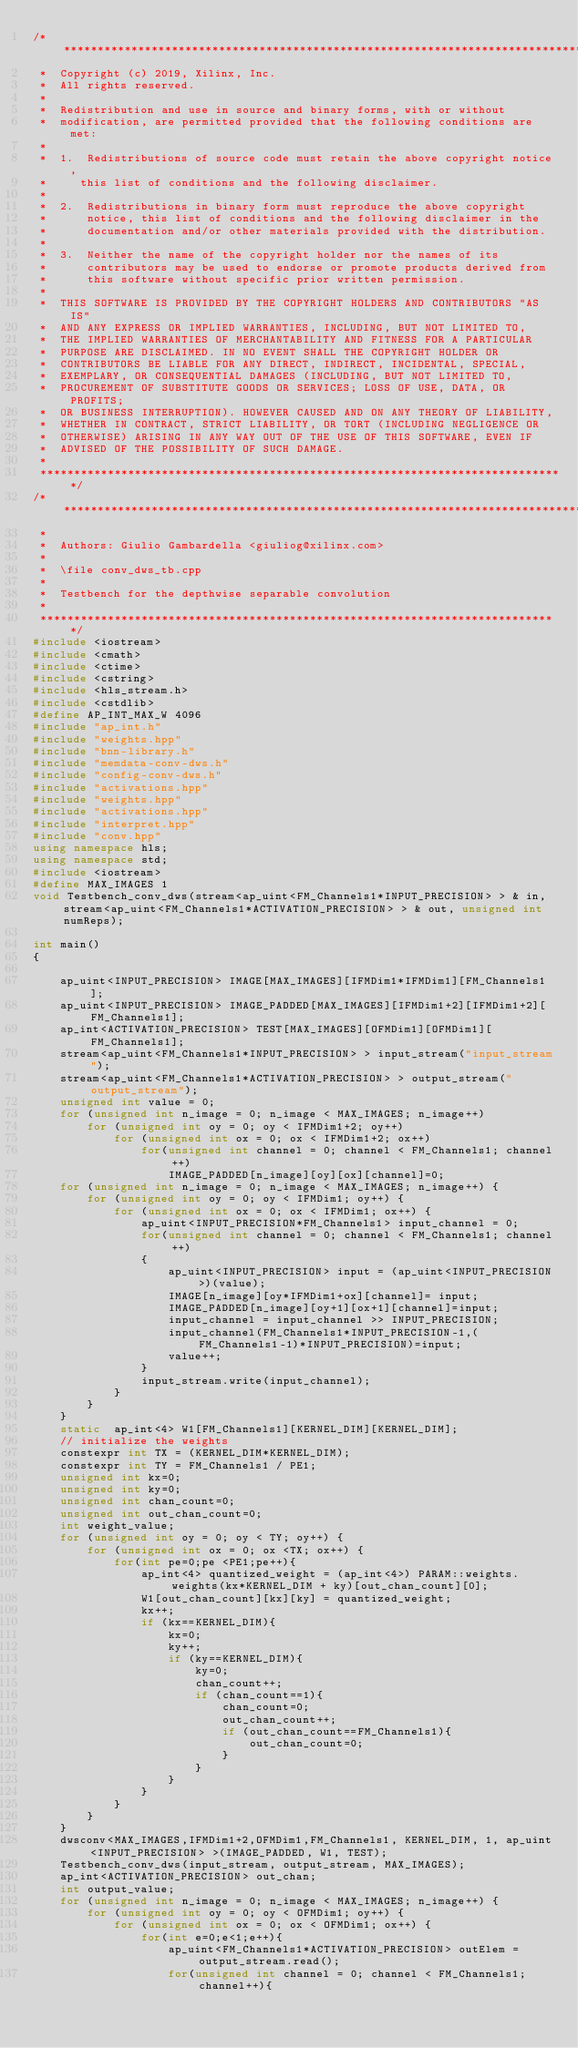<code> <loc_0><loc_0><loc_500><loc_500><_C++_>/******************************************************************************
 *  Copyright (c) 2019, Xilinx, Inc.
 *  All rights reserved.
 *
 *  Redistribution and use in source and binary forms, with or without
 *  modification, are permitted provided that the following conditions are met:
 *
 *  1.  Redistributions of source code must retain the above copyright notice,
 *     this list of conditions and the following disclaimer.
 *
 *  2.  Redistributions in binary form must reproduce the above copyright
 *      notice, this list of conditions and the following disclaimer in the
 *      documentation and/or other materials provided with the distribution.
 *
 *  3.  Neither the name of the copyright holder nor the names of its
 *      contributors may be used to endorse or promote products derived from
 *      this software without specific prior written permission.
 *
 *  THIS SOFTWARE IS PROVIDED BY THE COPYRIGHT HOLDERS AND CONTRIBUTORS "AS IS"
 *  AND ANY EXPRESS OR IMPLIED WARRANTIES, INCLUDING, BUT NOT LIMITED TO,
 *  THE IMPLIED WARRANTIES OF MERCHANTABILITY AND FITNESS FOR A PARTICULAR
 *  PURPOSE ARE DISCLAIMED. IN NO EVENT SHALL THE COPYRIGHT HOLDER OR
 *  CONTRIBUTORS BE LIABLE FOR ANY DIRECT, INDIRECT, INCIDENTAL, SPECIAL,
 *  EXEMPLARY, OR CONSEQUENTIAL DAMAGES (INCLUDING, BUT NOT LIMITED TO,
 *  PROCUREMENT OF SUBSTITUTE GOODS OR SERVICES; LOSS OF USE, DATA, OR PROFITS;
 *  OR BUSINESS INTERRUPTION). HOWEVER CAUSED AND ON ANY THEORY OF LIABILITY,
 *  WHETHER IN CONTRACT, STRICT LIABILITY, OR TORT (INCLUDING NEGLIGENCE OR
 *  OTHERWISE) ARISING IN ANY WAY OUT OF THE USE OF THIS SOFTWARE, EVEN IF
 *  ADVISED OF THE POSSIBILITY OF SUCH DAMAGE.
 *
 ******************************************************************************/
/******************************************************************************
 *
 *  Authors: Giulio Gambardella <giuliog@xilinx.com>
 *
 *  \file conv_dws_tb.cpp
 *
 *  Testbench for the depthwise separable convolution
 *
 *****************************************************************************/
#include <iostream>
#include <cmath>
#include <ctime>
#include <cstring>
#include <hls_stream.h>
#include <cstdlib>
#define AP_INT_MAX_W 4096
#include "ap_int.h"
#include "weights.hpp"
#include "bnn-library.h"
#include "memdata-conv-dws.h"
#include "config-conv-dws.h"
#include "activations.hpp"
#include "weights.hpp"
#include "activations.hpp"
#include "interpret.hpp"
#include "conv.hpp"
using namespace hls;
using namespace std;
#include <iostream>
#define MAX_IMAGES 1
void Testbench_conv_dws(stream<ap_uint<FM_Channels1*INPUT_PRECISION> > & in, stream<ap_uint<FM_Channels1*ACTIVATION_PRECISION> > & out, unsigned int numReps);

int main()
{

	ap_uint<INPUT_PRECISION> IMAGE[MAX_IMAGES][IFMDim1*IFMDim1][FM_Channels1];
	ap_uint<INPUT_PRECISION> IMAGE_PADDED[MAX_IMAGES][IFMDim1+2][IFMDim1+2][FM_Channels1];
	ap_int<ACTIVATION_PRECISION> TEST[MAX_IMAGES][OFMDim1][OFMDim1][FM_Channels1];
	stream<ap_uint<FM_Channels1*INPUT_PRECISION> > input_stream("input_stream");
	stream<ap_uint<FM_Channels1*ACTIVATION_PRECISION> > output_stream("output_stream");
	unsigned int value = 0;
	for (unsigned int n_image = 0; n_image < MAX_IMAGES; n_image++)
		for (unsigned int oy = 0; oy < IFMDim1+2; oy++)
			for (unsigned int ox = 0; ox < IFMDim1+2; ox++)
				for(unsigned int channel = 0; channel < FM_Channels1; channel++)
					IMAGE_PADDED[n_image][oy][ox][channel]=0;
	for (unsigned int n_image = 0; n_image < MAX_IMAGES; n_image++) {
		for (unsigned int oy = 0; oy < IFMDim1; oy++) {
			for (unsigned int ox = 0; ox < IFMDim1; ox++) {
				ap_uint<INPUT_PRECISION*FM_Channels1> input_channel = 0;
				for(unsigned int channel = 0; channel < FM_Channels1; channel++)
				{
					ap_uint<INPUT_PRECISION> input = (ap_uint<INPUT_PRECISION>)(value);
					IMAGE[n_image][oy*IFMDim1+ox][channel]= input;
					IMAGE_PADDED[n_image][oy+1][ox+1][channel]=input;
					input_channel = input_channel >> INPUT_PRECISION;
					input_channel(FM_Channels1*INPUT_PRECISION-1,(FM_Channels1-1)*INPUT_PRECISION)=input;
					value++;
				}
				input_stream.write(input_channel);
			}
		}
	}
	static	ap_int<4> W1[FM_Channels1][KERNEL_DIM][KERNEL_DIM];
	// initialize the weights
	constexpr int TX = (KERNEL_DIM*KERNEL_DIM);
	constexpr int TY = FM_Channels1 / PE1;
	unsigned int kx=0;
	unsigned int ky=0;
	unsigned int chan_count=0;
	unsigned int out_chan_count=0;
	int weight_value;
	for (unsigned int oy = 0; oy < TY; oy++) {
		for (unsigned int ox = 0; ox <TX; ox++) {
			for(int pe=0;pe <PE1;pe++){
				ap_int<4> quantized_weight = (ap_int<4>) PARAM::weights.weights(kx*KERNEL_DIM + ky)[out_chan_count][0];
				W1[out_chan_count][kx][ky] = quantized_weight;
				kx++;
				if (kx==KERNEL_DIM){
					kx=0;
					ky++;
					if (ky==KERNEL_DIM){
						ky=0;
						chan_count++;
						if (chan_count==1){
							chan_count=0;
							out_chan_count++;
							if (out_chan_count==FM_Channels1){
								out_chan_count=0;
							}
						}
					}
				}
			}
		}
	}
	dwsconv<MAX_IMAGES,IFMDim1+2,OFMDim1,FM_Channels1, KERNEL_DIM, 1, ap_uint<INPUT_PRECISION> >(IMAGE_PADDED, W1, TEST);
	Testbench_conv_dws(input_stream, output_stream, MAX_IMAGES);
	ap_int<ACTIVATION_PRECISION> out_chan;
	int output_value;
	for (unsigned int n_image = 0; n_image < MAX_IMAGES; n_image++) {
		for (unsigned int oy = 0; oy < OFMDim1; oy++) {
			for (unsigned int ox = 0; ox < OFMDim1; ox++) {
				for(int e=0;e<1;e++){
					ap_uint<FM_Channels1*ACTIVATION_PRECISION> outElem = output_stream.read();
					for(unsigned int channel = 0; channel < FM_Channels1; channel++){</code> 